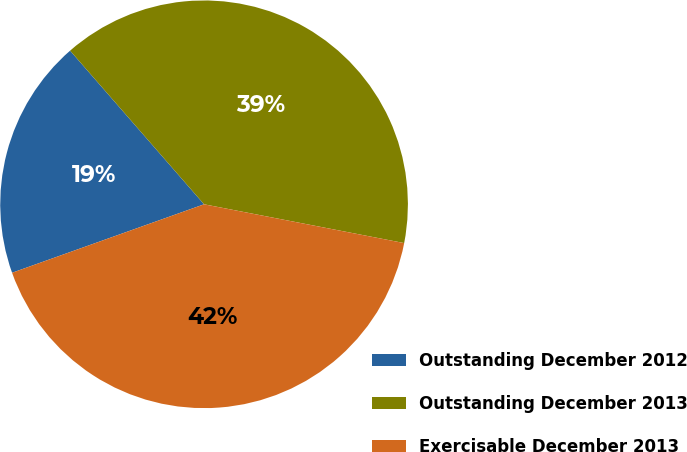Convert chart. <chart><loc_0><loc_0><loc_500><loc_500><pie_chart><fcel>Outstanding December 2012<fcel>Outstanding December 2013<fcel>Exercisable December 2013<nl><fcel>19.04%<fcel>39.46%<fcel>41.5%<nl></chart> 